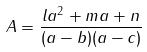Convert formula to latex. <formula><loc_0><loc_0><loc_500><loc_500>A = \frac { l a ^ { 2 } + m a + n } { ( a - b ) ( a - c ) }</formula> 